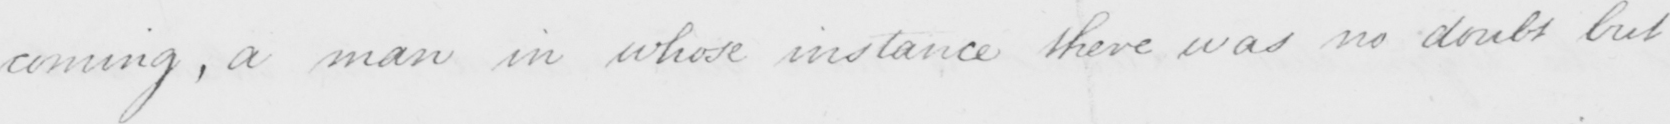Please provide the text content of this handwritten line. -coming , a man in whose instance there was no doubt but 